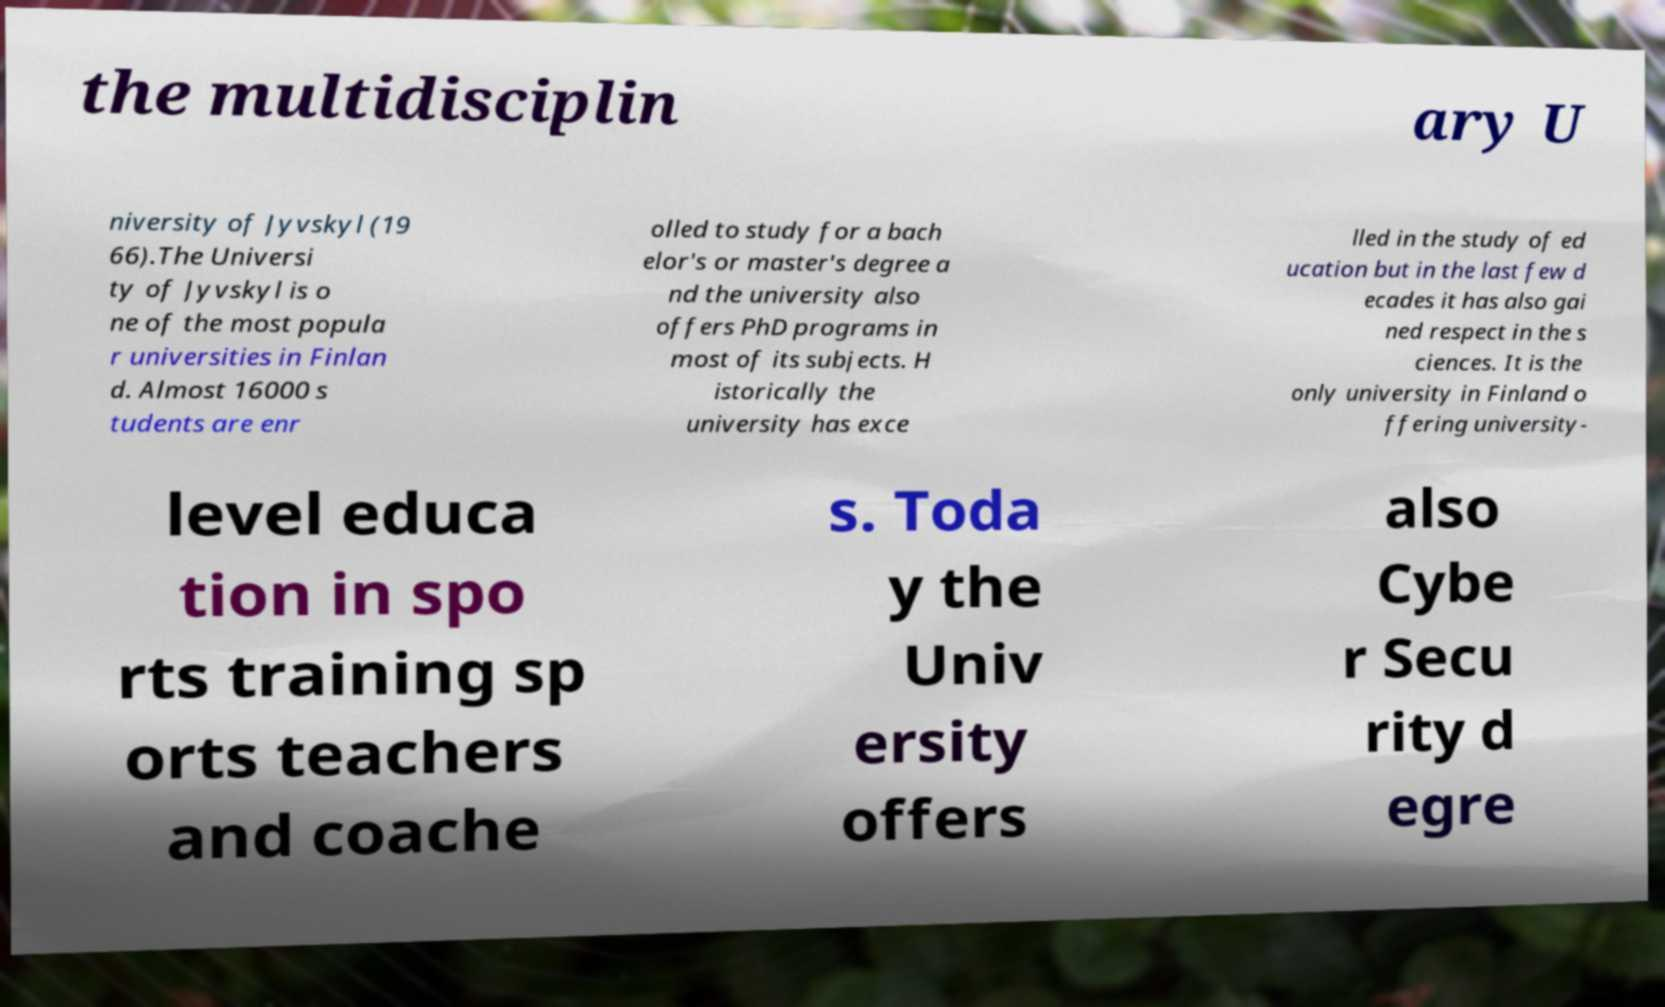There's text embedded in this image that I need extracted. Can you transcribe it verbatim? the multidisciplin ary U niversity of Jyvskyl (19 66).The Universi ty of Jyvskyl is o ne of the most popula r universities in Finlan d. Almost 16000 s tudents are enr olled to study for a bach elor's or master's degree a nd the university also offers PhD programs in most of its subjects. H istorically the university has exce lled in the study of ed ucation but in the last few d ecades it has also gai ned respect in the s ciences. It is the only university in Finland o ffering university- level educa tion in spo rts training sp orts teachers and coache s. Toda y the Univ ersity offers also Cybe r Secu rity d egre 